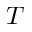Convert formula to latex. <formula><loc_0><loc_0><loc_500><loc_500>T</formula> 